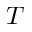Convert formula to latex. <formula><loc_0><loc_0><loc_500><loc_500>T</formula> 